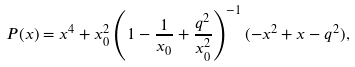Convert formula to latex. <formula><loc_0><loc_0><loc_500><loc_500>P ( x ) = x ^ { 4 } + x _ { 0 } ^ { 2 } \left ( 1 - \frac { 1 } { x _ { 0 } } + \frac { q ^ { 2 } } { x _ { 0 } ^ { 2 } } \right ) ^ { - 1 } ( - x ^ { 2 } + x - q ^ { 2 } ) ,</formula> 